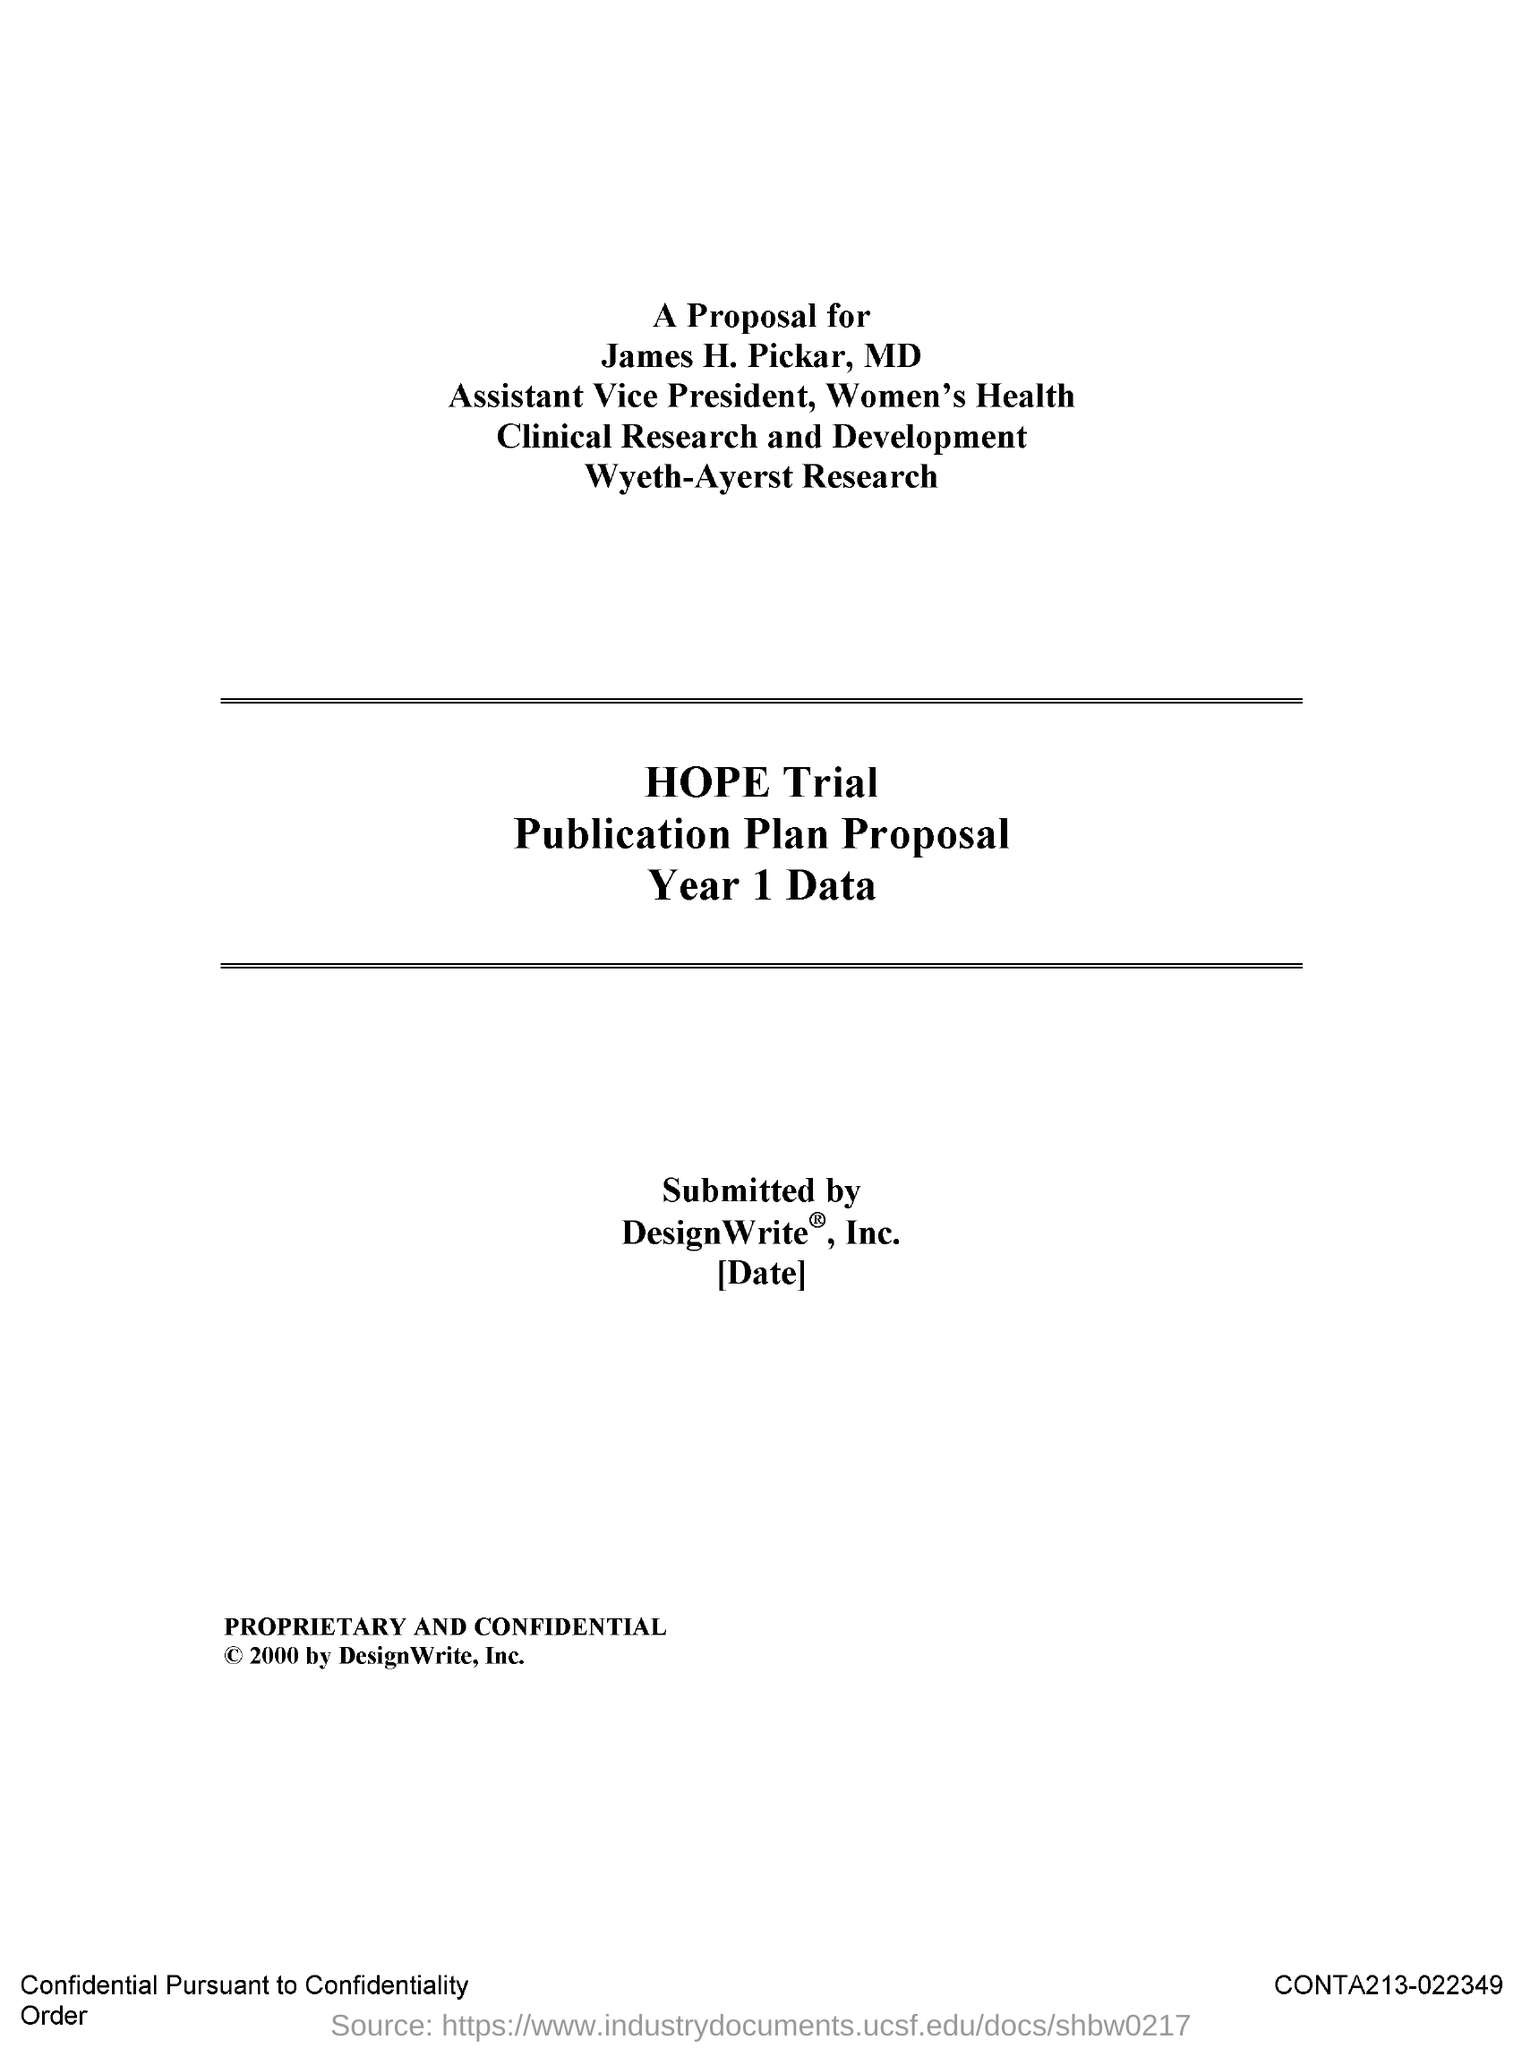What is the designation of james h. pickar ?
Your response must be concise. Assistant vice president. 